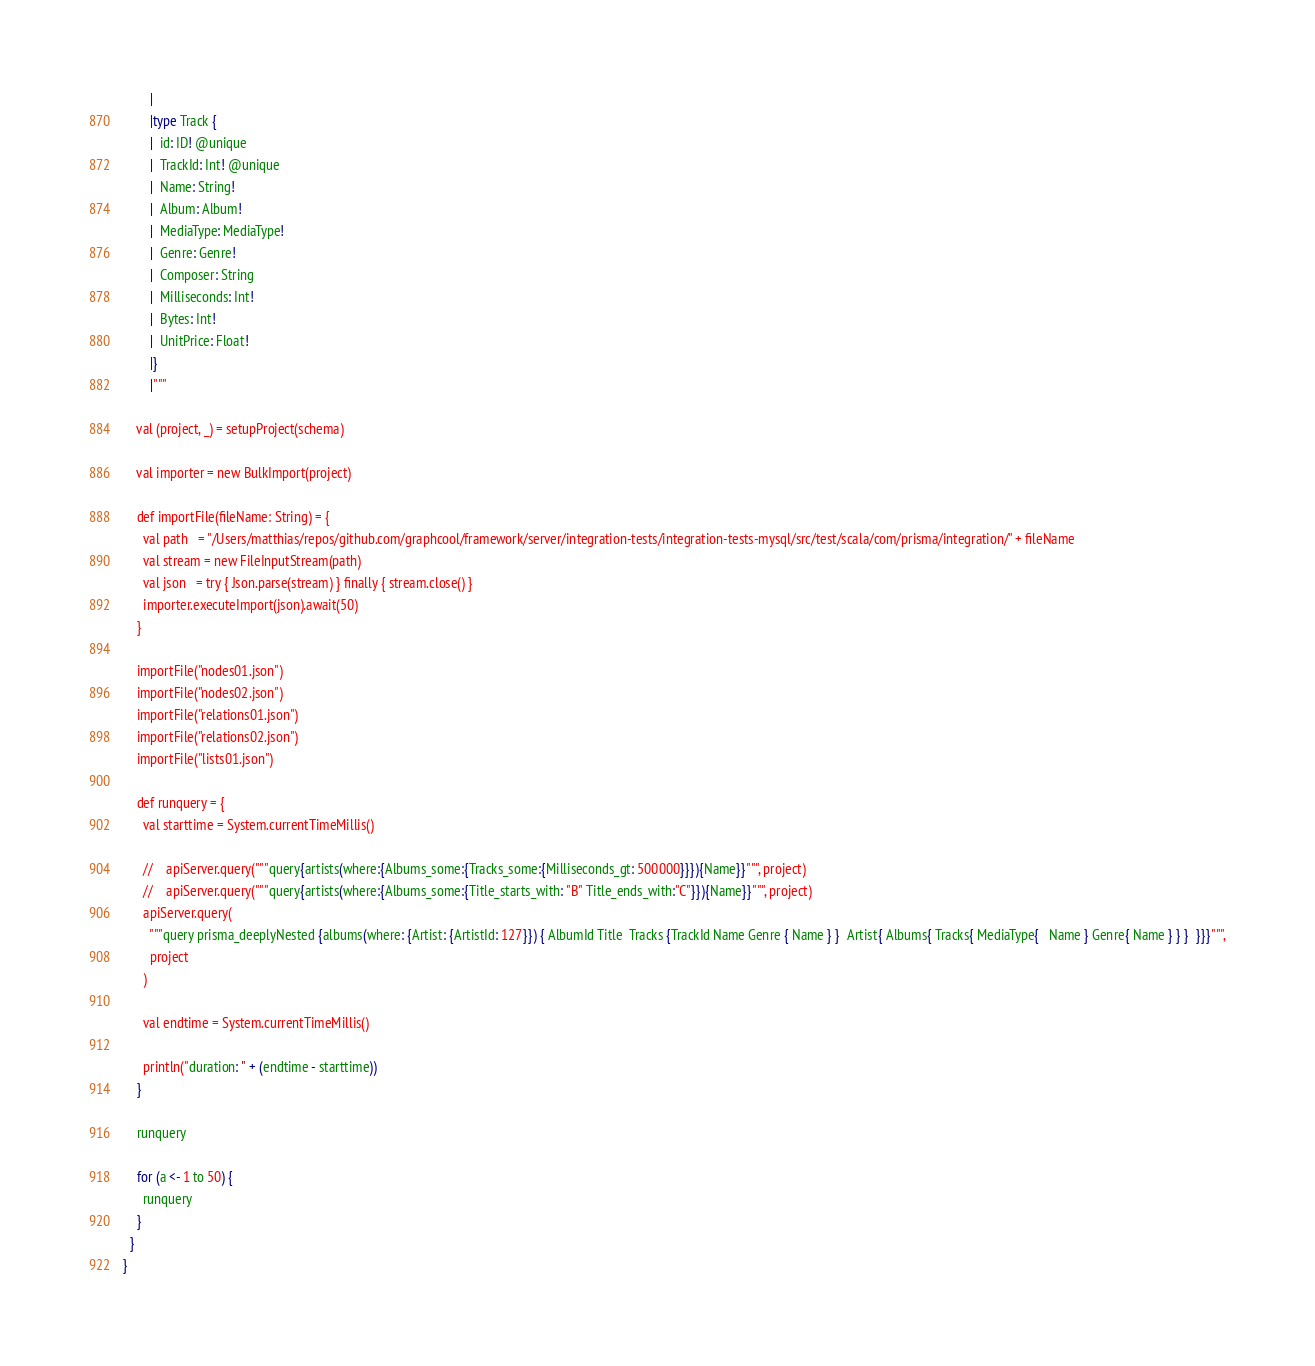<code> <loc_0><loc_0><loc_500><loc_500><_Scala_>        |
        |type Track {
        |  id: ID! @unique
        |  TrackId: Int! @unique
        |  Name: String!
        |  Album: Album!
        |  MediaType: MediaType!
        |  Genre: Genre!
        |  Composer: String
        |  Milliseconds: Int!
        |  Bytes: Int!
        |  UnitPrice: Float!
        |}
        |"""

    val (project, _) = setupProject(schema)

    val importer = new BulkImport(project)

    def importFile(fileName: String) = {
      val path   = "/Users/matthias/repos/github.com/graphcool/framework/server/integration-tests/integration-tests-mysql/src/test/scala/com/prisma/integration/" + fileName
      val stream = new FileInputStream(path)
      val json   = try { Json.parse(stream) } finally { stream.close() }
      importer.executeImport(json).await(50)
    }

    importFile("nodes01.json")
    importFile("nodes02.json")
    importFile("relations01.json")
    importFile("relations02.json")
    importFile("lists01.json")

    def runquery = {
      val starttime = System.currentTimeMillis()

      //    apiServer.query("""query{artists(where:{Albums_some:{Tracks_some:{Milliseconds_gt: 500000}}}){Name}}""", project)
      //    apiServer.query("""query{artists(where:{Albums_some:{Title_starts_with: "B" Title_ends_with:"C"}}){Name}}""", project)
      apiServer.query(
        """query prisma_deeplyNested {albums(where: {Artist: {ArtistId: 127}}) { AlbumId Title  Tracks {TrackId Name Genre { Name } }  Artist{ Albums{ Tracks{ MediaType{   Name } Genre{ Name } } }  }}}""",
        project
      )

      val endtime = System.currentTimeMillis()

      println("duration: " + (endtime - starttime))
    }

    runquery

    for (a <- 1 to 50) {
      runquery
    }
  }
}
</code> 